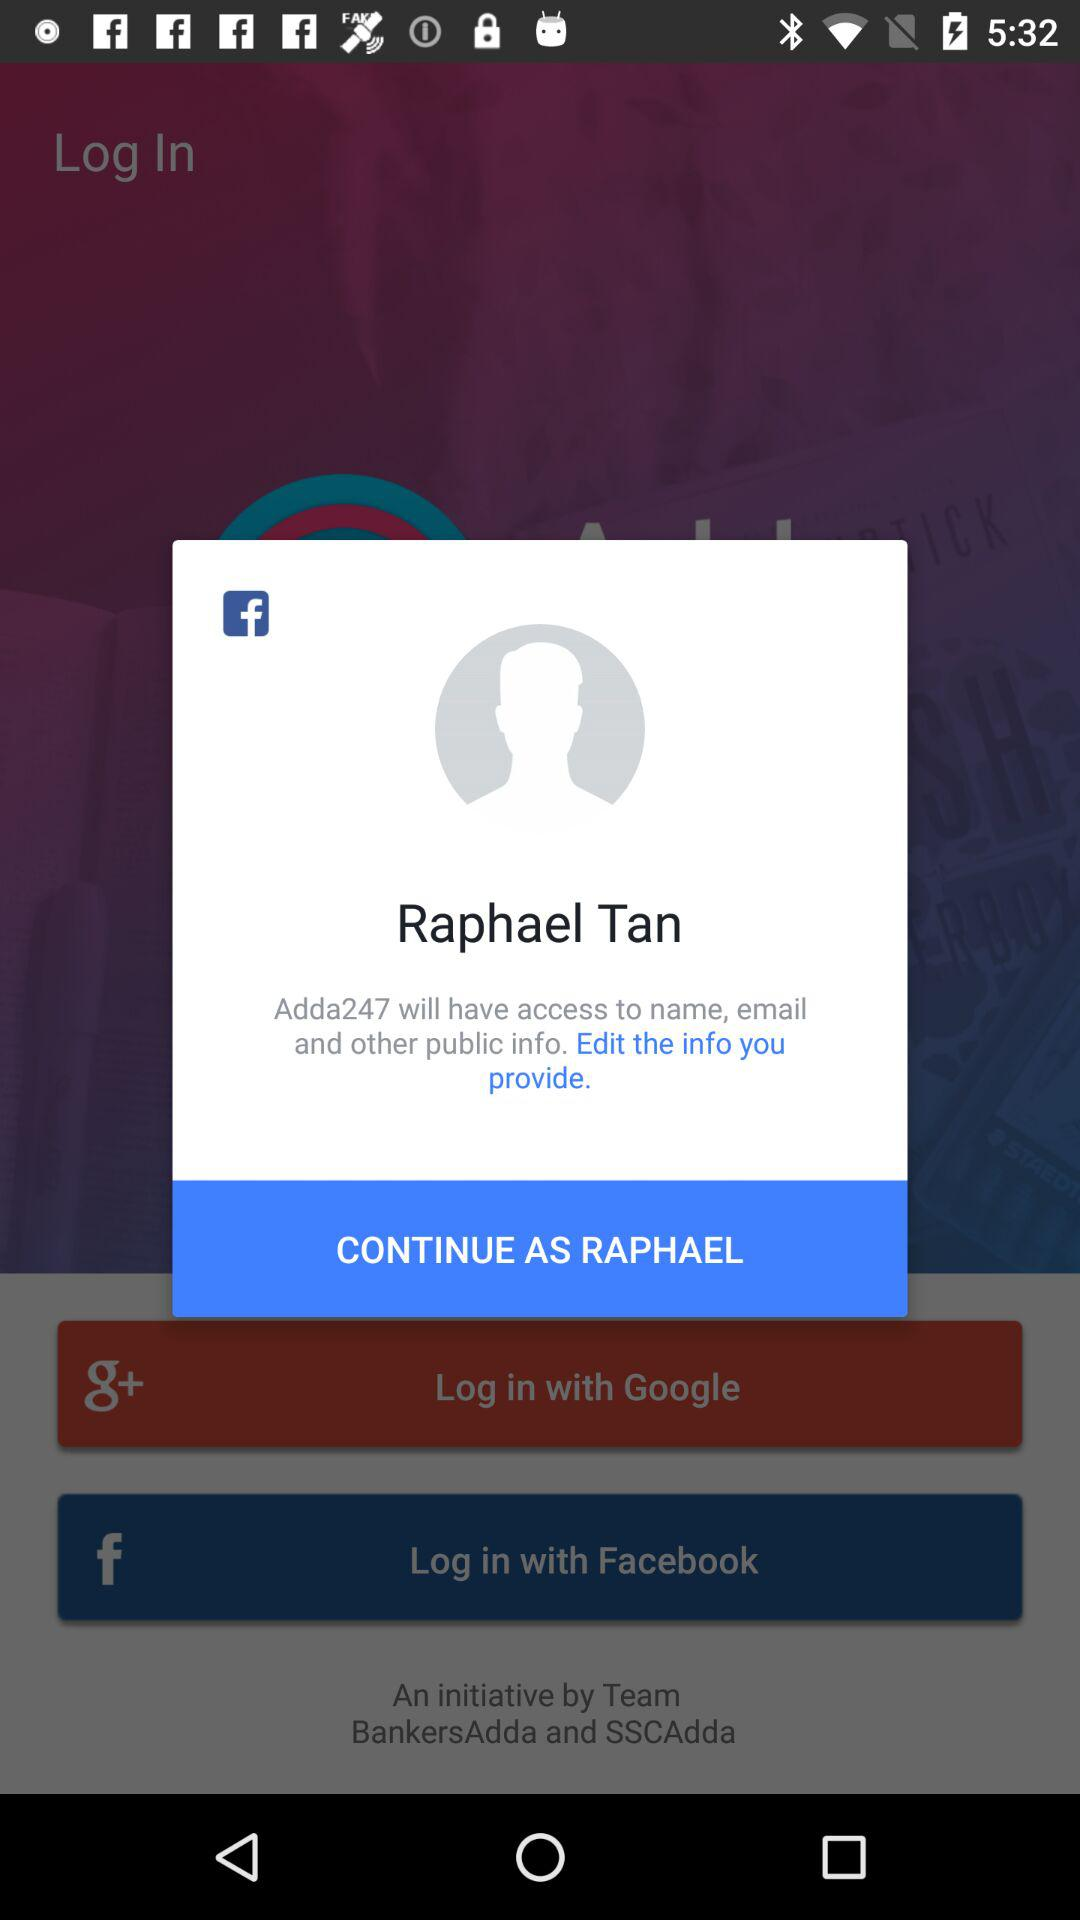How can we log in? You can log in with "Google" and "Facebook". 